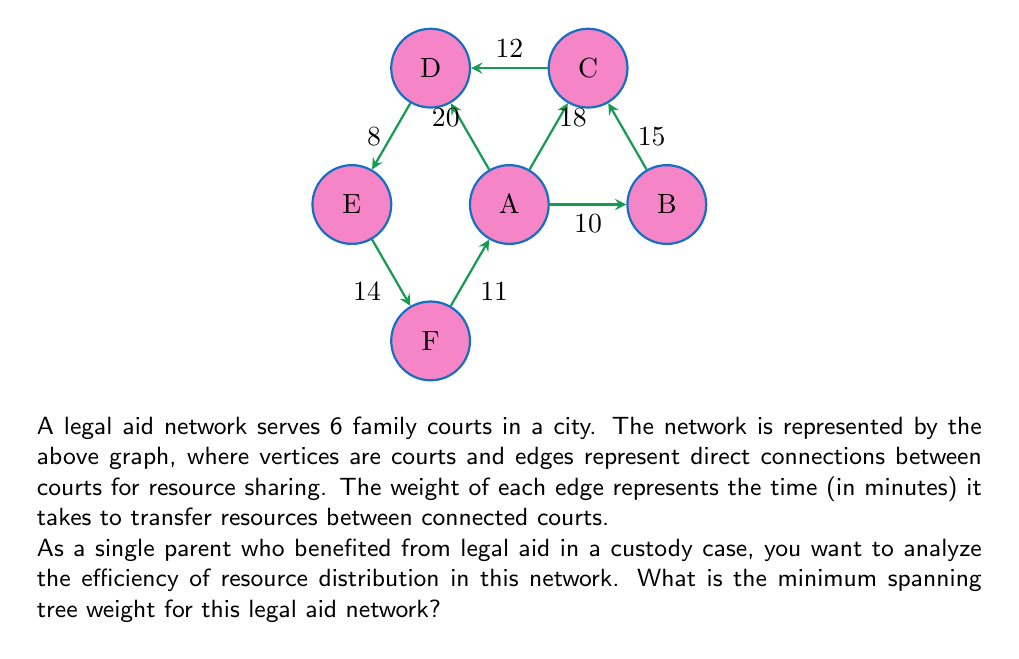Teach me how to tackle this problem. To find the minimum spanning tree (MST) weight, we'll use Kruskal's algorithm:

1) Sort edges by weight in ascending order:
   8 (D-E), 10 (A-B), 11 (F-A), 12 (C-D), 14 (E-F), 15 (B-C), 18 (A-C), 20 (A-D)

2) Add edges to the MST, skipping those that form cycles:

   - Add D-E (8)
   - Add A-B (10)
   - Add F-A (11)
   - Add C-D (12)
   - Add B-C (15)

3) The MST is complete with 5 edges (for 6 vertices).

4) Calculate the total weight:
   $$\text{MST Weight} = 8 + 10 + 11 + 12 + 15 = 56$$

This MST ensures efficient resource sharing among all courts with minimal transfer time.
Answer: 56 minutes 